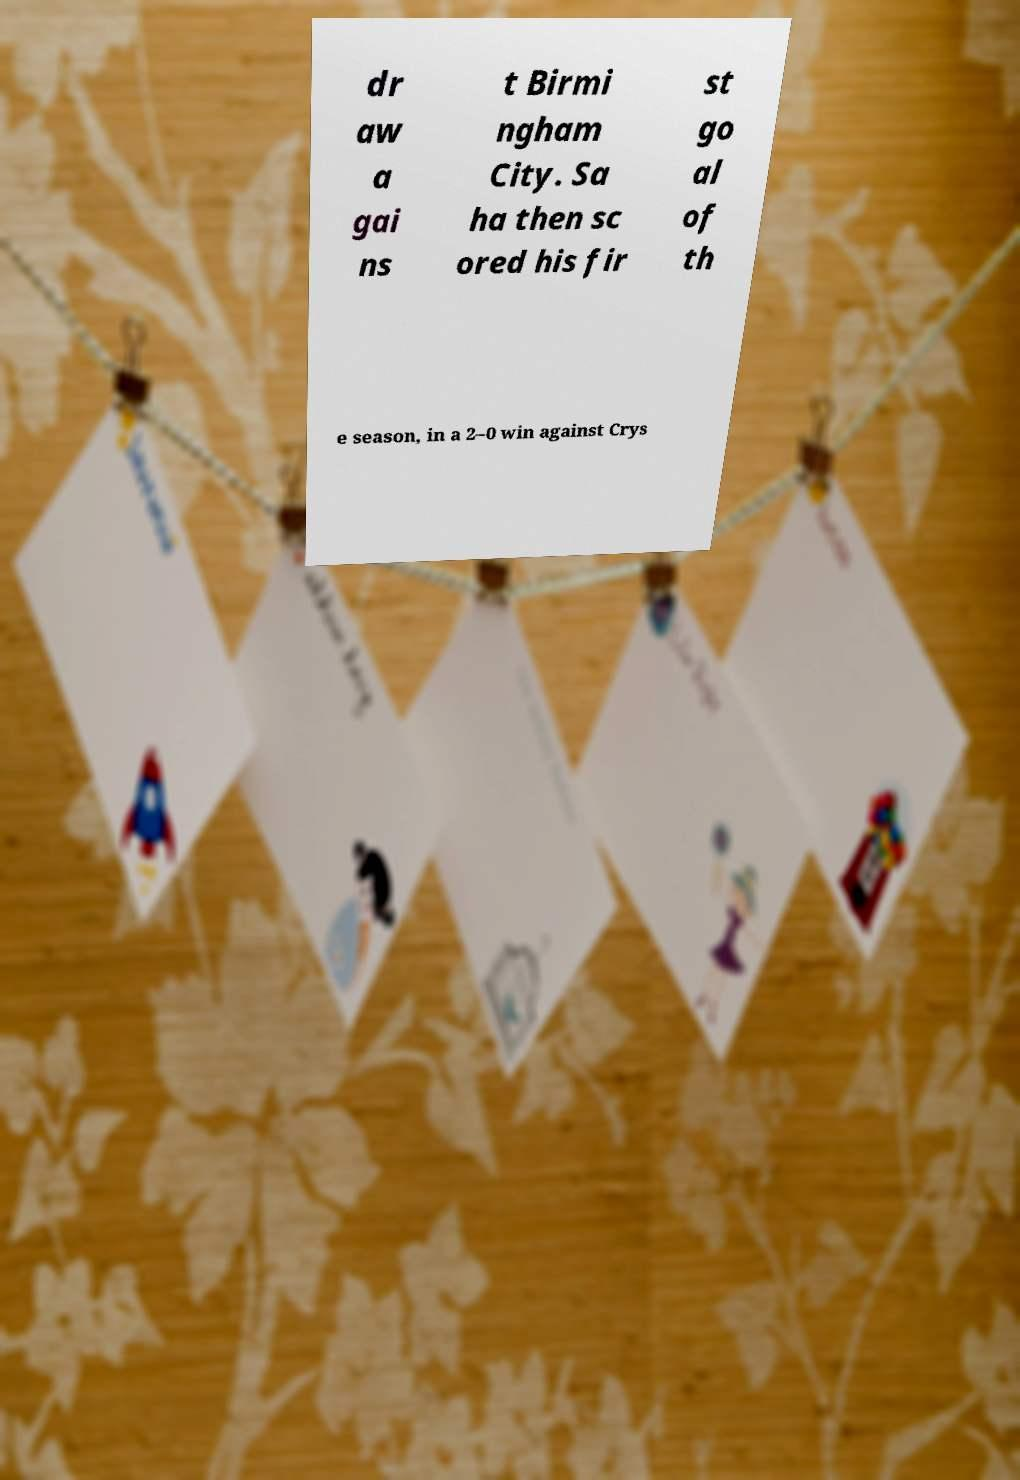There's text embedded in this image that I need extracted. Can you transcribe it verbatim? dr aw a gai ns t Birmi ngham City. Sa ha then sc ored his fir st go al of th e season, in a 2–0 win against Crys 